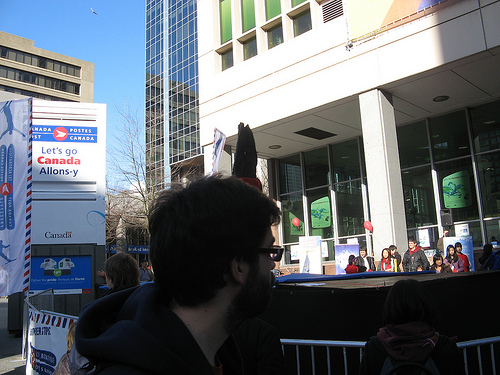<image>
Can you confirm if the glasses is on the woman? No. The glasses is not positioned on the woman. They may be near each other, but the glasses is not supported by or resting on top of the woman. 